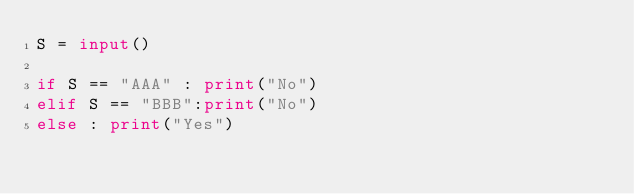Convert code to text. <code><loc_0><loc_0><loc_500><loc_500><_Python_>S = input()

if S == "AAA" : print("No")
elif S == "BBB":print("No")
else : print("Yes")</code> 